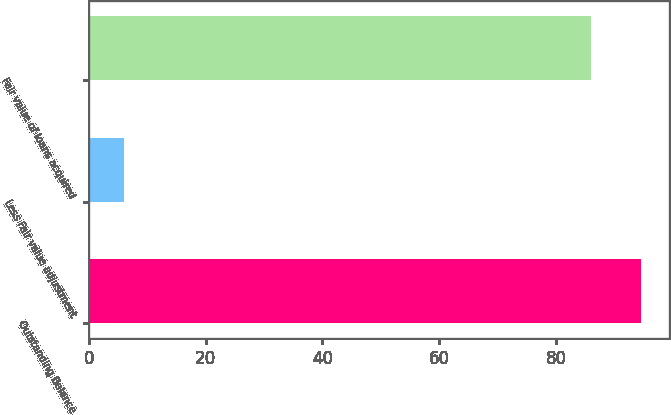Convert chart. <chart><loc_0><loc_0><loc_500><loc_500><bar_chart><fcel>Outstanding Balance<fcel>Less Fair value adjustment<fcel>Fair value of loans acquired<nl><fcel>94.6<fcel>6<fcel>86<nl></chart> 